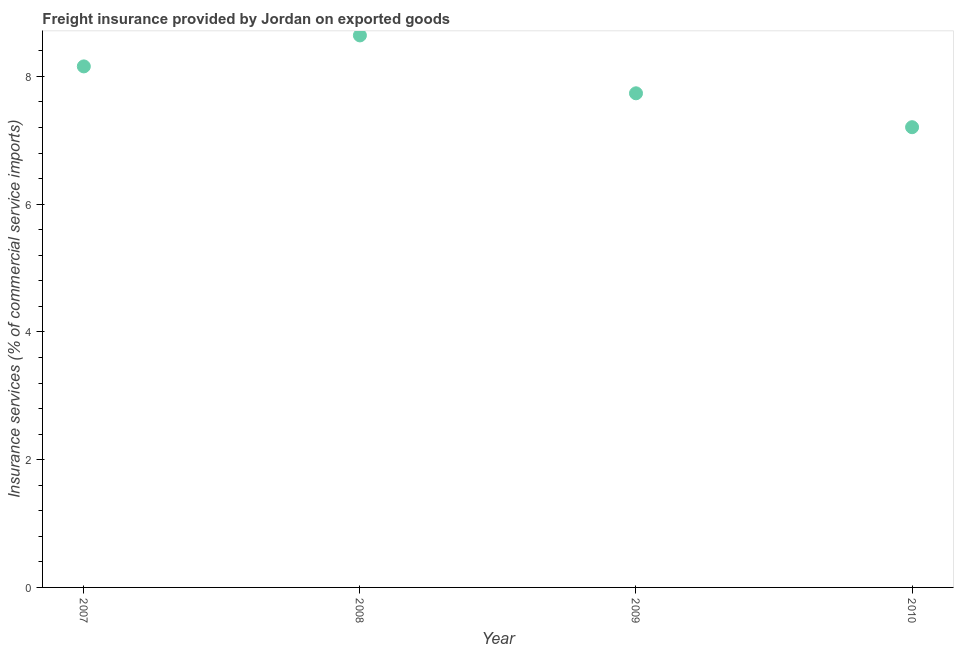What is the freight insurance in 2009?
Provide a short and direct response. 7.74. Across all years, what is the maximum freight insurance?
Give a very brief answer. 8.64. Across all years, what is the minimum freight insurance?
Your response must be concise. 7.21. In which year was the freight insurance maximum?
Ensure brevity in your answer.  2008. What is the sum of the freight insurance?
Your response must be concise. 31.74. What is the difference between the freight insurance in 2009 and 2010?
Give a very brief answer. 0.53. What is the average freight insurance per year?
Your answer should be compact. 7.94. What is the median freight insurance?
Your response must be concise. 7.95. What is the ratio of the freight insurance in 2009 to that in 2010?
Make the answer very short. 1.07. Is the freight insurance in 2009 less than that in 2010?
Give a very brief answer. No. Is the difference between the freight insurance in 2008 and 2010 greater than the difference between any two years?
Your answer should be compact. Yes. What is the difference between the highest and the second highest freight insurance?
Your response must be concise. 0.49. What is the difference between the highest and the lowest freight insurance?
Make the answer very short. 1.44. In how many years, is the freight insurance greater than the average freight insurance taken over all years?
Keep it short and to the point. 2. What is the difference between two consecutive major ticks on the Y-axis?
Offer a terse response. 2. What is the title of the graph?
Give a very brief answer. Freight insurance provided by Jordan on exported goods . What is the label or title of the Y-axis?
Your answer should be compact. Insurance services (% of commercial service imports). What is the Insurance services (% of commercial service imports) in 2007?
Your answer should be compact. 8.16. What is the Insurance services (% of commercial service imports) in 2008?
Offer a terse response. 8.64. What is the Insurance services (% of commercial service imports) in 2009?
Make the answer very short. 7.74. What is the Insurance services (% of commercial service imports) in 2010?
Give a very brief answer. 7.21. What is the difference between the Insurance services (% of commercial service imports) in 2007 and 2008?
Offer a very short reply. -0.49. What is the difference between the Insurance services (% of commercial service imports) in 2007 and 2009?
Your answer should be compact. 0.42. What is the difference between the Insurance services (% of commercial service imports) in 2007 and 2010?
Provide a short and direct response. 0.95. What is the difference between the Insurance services (% of commercial service imports) in 2008 and 2009?
Provide a short and direct response. 0.91. What is the difference between the Insurance services (% of commercial service imports) in 2008 and 2010?
Give a very brief answer. 1.44. What is the difference between the Insurance services (% of commercial service imports) in 2009 and 2010?
Your answer should be compact. 0.53. What is the ratio of the Insurance services (% of commercial service imports) in 2007 to that in 2008?
Provide a succinct answer. 0.94. What is the ratio of the Insurance services (% of commercial service imports) in 2007 to that in 2009?
Ensure brevity in your answer.  1.05. What is the ratio of the Insurance services (% of commercial service imports) in 2007 to that in 2010?
Make the answer very short. 1.13. What is the ratio of the Insurance services (% of commercial service imports) in 2008 to that in 2009?
Keep it short and to the point. 1.12. What is the ratio of the Insurance services (% of commercial service imports) in 2008 to that in 2010?
Your answer should be compact. 1.2. What is the ratio of the Insurance services (% of commercial service imports) in 2009 to that in 2010?
Keep it short and to the point. 1.07. 